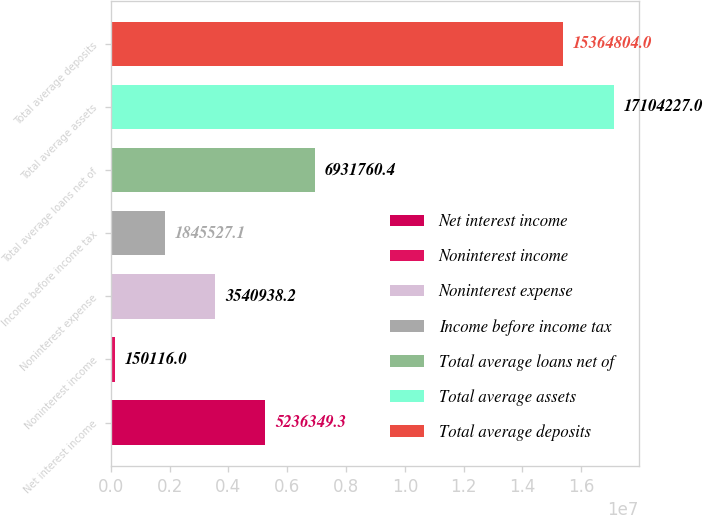Convert chart. <chart><loc_0><loc_0><loc_500><loc_500><bar_chart><fcel>Net interest income<fcel>Noninterest income<fcel>Noninterest expense<fcel>Income before income tax<fcel>Total average loans net of<fcel>Total average assets<fcel>Total average deposits<nl><fcel>5.23635e+06<fcel>150116<fcel>3.54094e+06<fcel>1.84553e+06<fcel>6.93176e+06<fcel>1.71042e+07<fcel>1.53648e+07<nl></chart> 